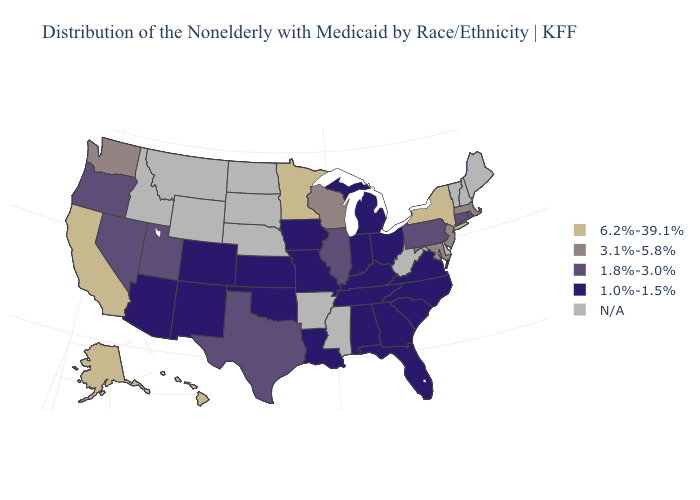What is the value of Virginia?
Concise answer only. 1.0%-1.5%. Name the states that have a value in the range N/A?
Short answer required. Arkansas, Delaware, Idaho, Maine, Mississippi, Montana, Nebraska, New Hampshire, North Dakota, South Dakota, Vermont, West Virginia, Wyoming. Does Wisconsin have the highest value in the USA?
Give a very brief answer. No. Does Utah have the highest value in the West?
Short answer required. No. Name the states that have a value in the range 1.8%-3.0%?
Keep it brief. Connecticut, Illinois, Nevada, Oregon, Pennsylvania, Rhode Island, Texas, Utah. Name the states that have a value in the range 6.2%-39.1%?
Answer briefly. Alaska, California, Hawaii, Minnesota, New York. Is the legend a continuous bar?
Keep it brief. No. Which states hav the highest value in the MidWest?
Concise answer only. Minnesota. Does Michigan have the highest value in the USA?
Keep it brief. No. What is the value of South Carolina?
Be succinct. 1.0%-1.5%. Does New York have the highest value in the USA?
Quick response, please. Yes. Among the states that border Mississippi , which have the lowest value?
Concise answer only. Alabama, Louisiana, Tennessee. What is the lowest value in states that border Louisiana?
Keep it brief. 1.8%-3.0%. Name the states that have a value in the range 1.8%-3.0%?
Write a very short answer. Connecticut, Illinois, Nevada, Oregon, Pennsylvania, Rhode Island, Texas, Utah. 